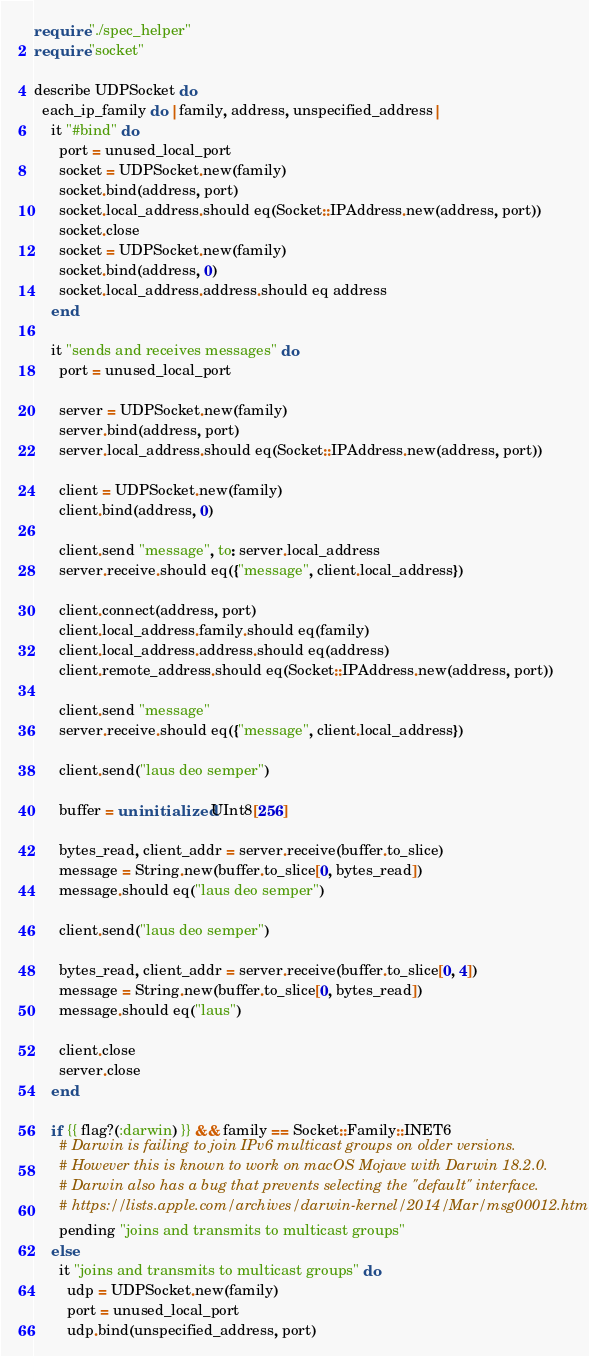<code> <loc_0><loc_0><loc_500><loc_500><_Crystal_>require "./spec_helper"
require "socket"

describe UDPSocket do
  each_ip_family do |family, address, unspecified_address|
    it "#bind" do
      port = unused_local_port
      socket = UDPSocket.new(family)
      socket.bind(address, port)
      socket.local_address.should eq(Socket::IPAddress.new(address, port))
      socket.close
      socket = UDPSocket.new(family)
      socket.bind(address, 0)
      socket.local_address.address.should eq address
    end

    it "sends and receives messages" do
      port = unused_local_port

      server = UDPSocket.new(family)
      server.bind(address, port)
      server.local_address.should eq(Socket::IPAddress.new(address, port))

      client = UDPSocket.new(family)
      client.bind(address, 0)

      client.send "message", to: server.local_address
      server.receive.should eq({"message", client.local_address})

      client.connect(address, port)
      client.local_address.family.should eq(family)
      client.local_address.address.should eq(address)
      client.remote_address.should eq(Socket::IPAddress.new(address, port))

      client.send "message"
      server.receive.should eq({"message", client.local_address})

      client.send("laus deo semper")

      buffer = uninitialized UInt8[256]

      bytes_read, client_addr = server.receive(buffer.to_slice)
      message = String.new(buffer.to_slice[0, bytes_read])
      message.should eq("laus deo semper")

      client.send("laus deo semper")

      bytes_read, client_addr = server.receive(buffer.to_slice[0, 4])
      message = String.new(buffer.to_slice[0, bytes_read])
      message.should eq("laus")

      client.close
      server.close
    end

    if {{ flag?(:darwin) }} && family == Socket::Family::INET6
      # Darwin is failing to join IPv6 multicast groups on older versions.
      # However this is known to work on macOS Mojave with Darwin 18.2.0.
      # Darwin also has a bug that prevents selecting the "default" interface.
      # https://lists.apple.com/archives/darwin-kernel/2014/Mar/msg00012.html
      pending "joins and transmits to multicast groups"
    else
      it "joins and transmits to multicast groups" do
        udp = UDPSocket.new(family)
        port = unused_local_port
        udp.bind(unspecified_address, port)
</code> 